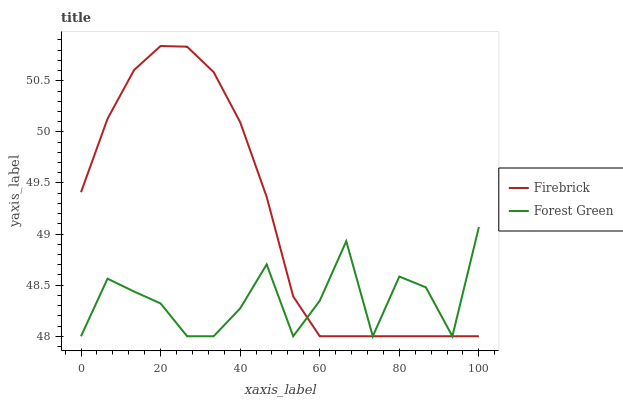Does Forest Green have the minimum area under the curve?
Answer yes or no. Yes. Does Firebrick have the maximum area under the curve?
Answer yes or no. Yes. Does Forest Green have the maximum area under the curve?
Answer yes or no. No. Is Firebrick the smoothest?
Answer yes or no. Yes. Is Forest Green the roughest?
Answer yes or no. Yes. Is Forest Green the smoothest?
Answer yes or no. No. Does Firebrick have the highest value?
Answer yes or no. Yes. Does Forest Green have the highest value?
Answer yes or no. No. Does Forest Green intersect Firebrick?
Answer yes or no. Yes. Is Forest Green less than Firebrick?
Answer yes or no. No. Is Forest Green greater than Firebrick?
Answer yes or no. No. 